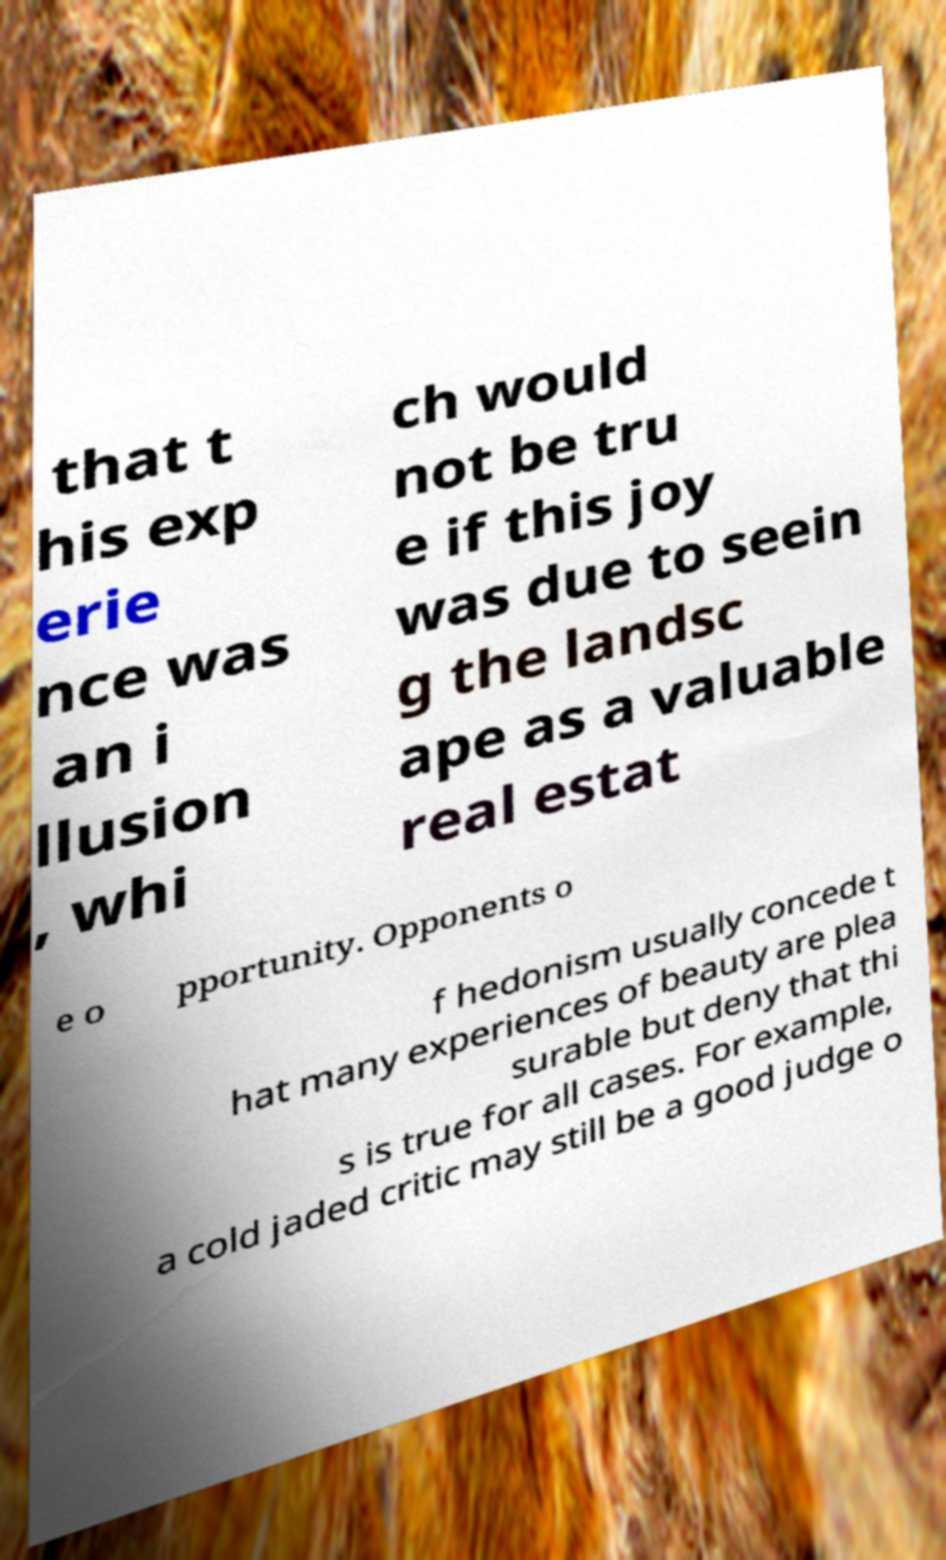What messages or text are displayed in this image? I need them in a readable, typed format. that t his exp erie nce was an i llusion , whi ch would not be tru e if this joy was due to seein g the landsc ape as a valuable real estat e o pportunity. Opponents o f hedonism usually concede t hat many experiences of beauty are plea surable but deny that thi s is true for all cases. For example, a cold jaded critic may still be a good judge o 